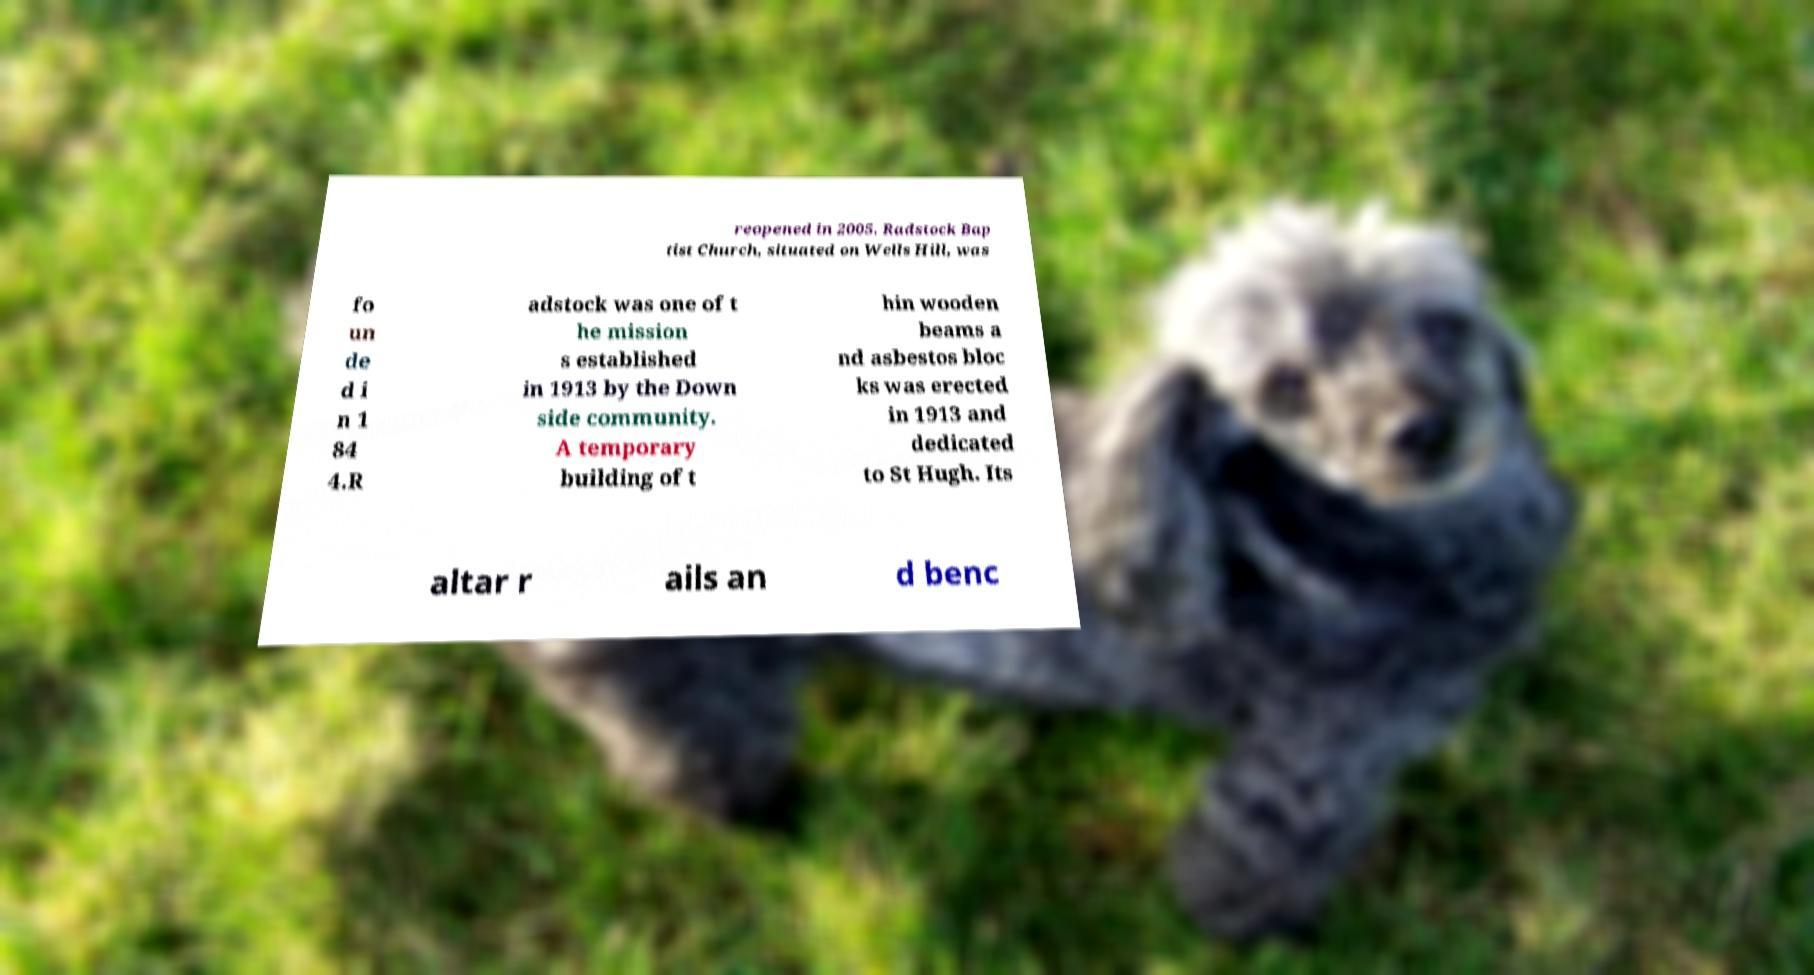Could you extract and type out the text from this image? reopened in 2005. Radstock Bap tist Church, situated on Wells Hill, was fo un de d i n 1 84 4.R adstock was one of t he mission s established in 1913 by the Down side community. A temporary building of t hin wooden beams a nd asbestos bloc ks was erected in 1913 and dedicated to St Hugh. Its altar r ails an d benc 